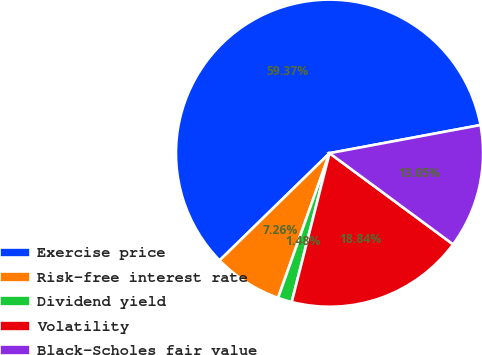<chart> <loc_0><loc_0><loc_500><loc_500><pie_chart><fcel>Exercise price<fcel>Risk-free interest rate<fcel>Dividend yield<fcel>Volatility<fcel>Black-Scholes fair value<nl><fcel>59.37%<fcel>7.26%<fcel>1.48%<fcel>18.84%<fcel>13.05%<nl></chart> 